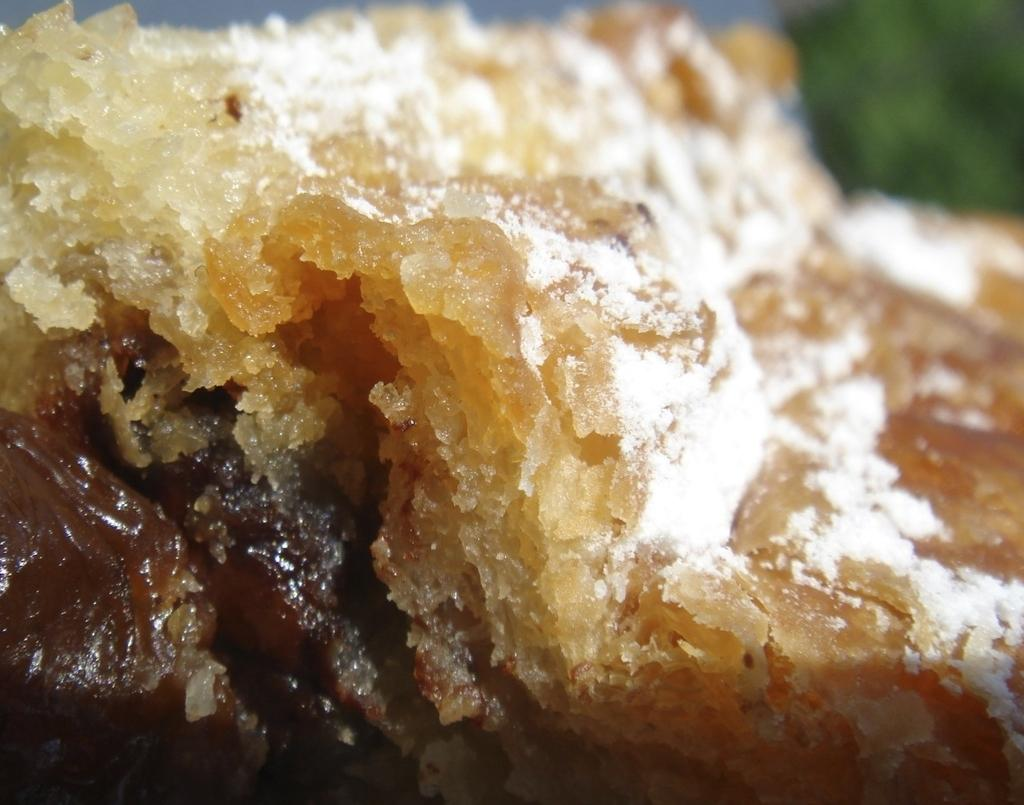What is the main subject of the image? There is a food item in the center of the image. How many chairs are placed around the food item in the image? There is no information about chairs or any other furniture in the image, so we cannot determine the number of chairs. 